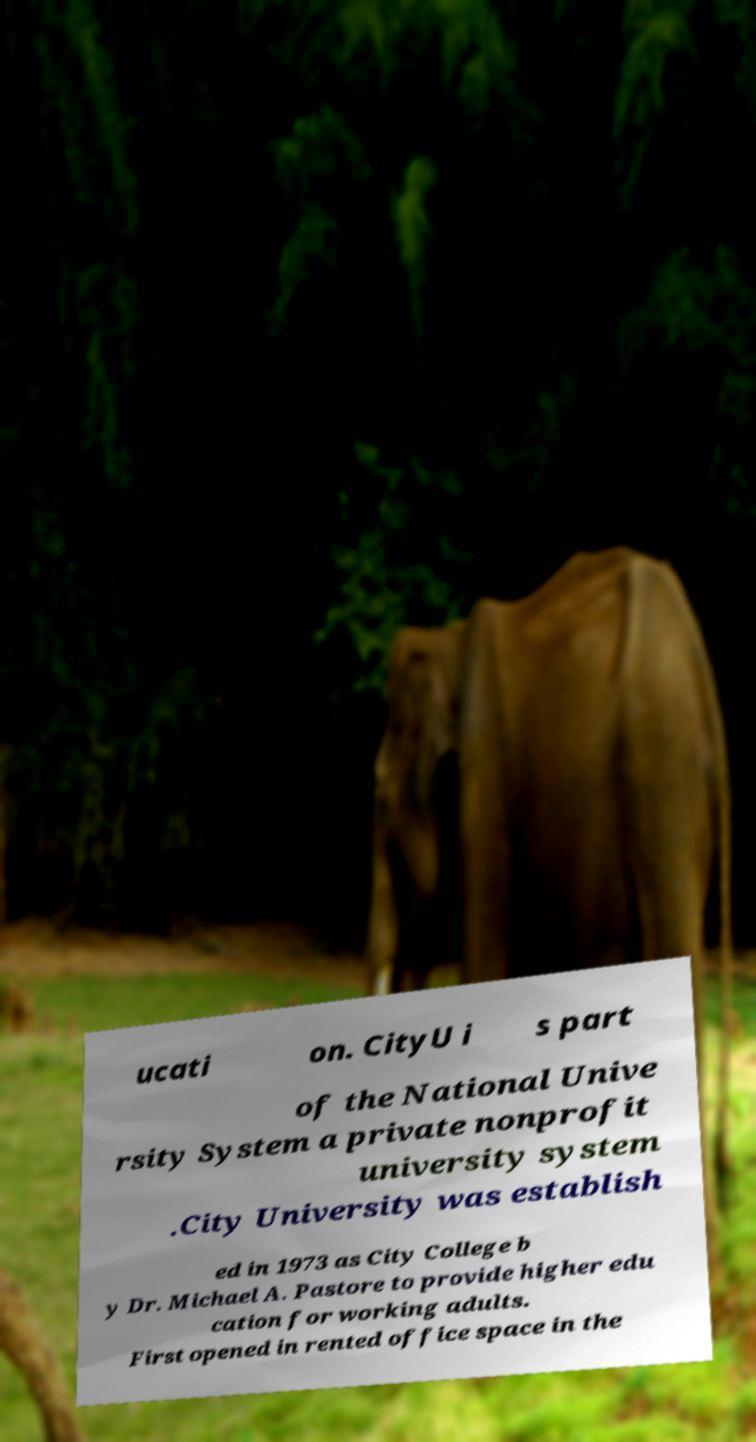Can you read and provide the text displayed in the image?This photo seems to have some interesting text. Can you extract and type it out for me? ucati on. CityU i s part of the National Unive rsity System a private nonprofit university system .City University was establish ed in 1973 as City College b y Dr. Michael A. Pastore to provide higher edu cation for working adults. First opened in rented office space in the 